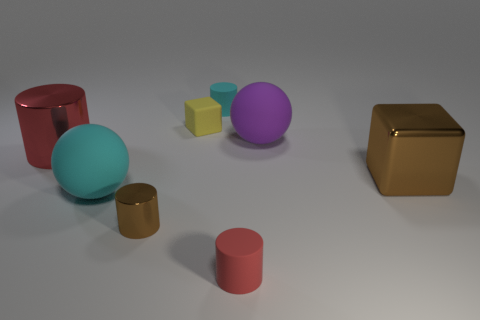Subtract all small cylinders. How many cylinders are left? 1 Add 1 big purple matte blocks. How many objects exist? 9 Subtract all gray cylinders. Subtract all cyan balls. How many cylinders are left? 4 Subtract all cubes. How many objects are left? 6 Add 1 small brown cylinders. How many small brown cylinders are left? 2 Add 4 tiny red objects. How many tiny red objects exist? 5 Subtract 1 yellow cubes. How many objects are left? 7 Subtract all tiny metallic objects. Subtract all yellow things. How many objects are left? 6 